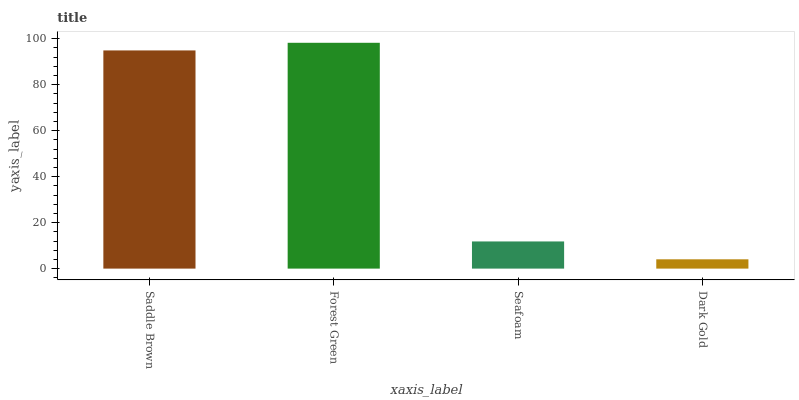Is Dark Gold the minimum?
Answer yes or no. Yes. Is Forest Green the maximum?
Answer yes or no. Yes. Is Seafoam the minimum?
Answer yes or no. No. Is Seafoam the maximum?
Answer yes or no. No. Is Forest Green greater than Seafoam?
Answer yes or no. Yes. Is Seafoam less than Forest Green?
Answer yes or no. Yes. Is Seafoam greater than Forest Green?
Answer yes or no. No. Is Forest Green less than Seafoam?
Answer yes or no. No. Is Saddle Brown the high median?
Answer yes or no. Yes. Is Seafoam the low median?
Answer yes or no. Yes. Is Seafoam the high median?
Answer yes or no. No. Is Forest Green the low median?
Answer yes or no. No. 